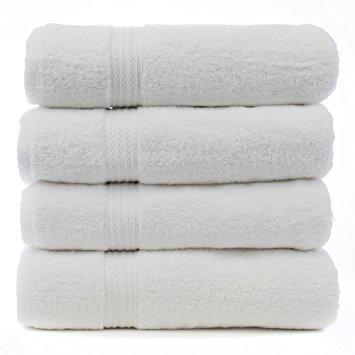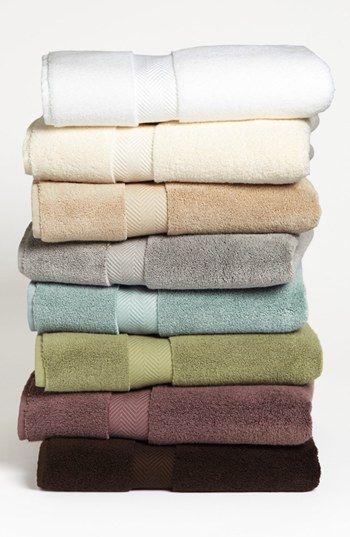The first image is the image on the left, the second image is the image on the right. Given the left and right images, does the statement "There are multiple colors of towels in the right image." hold true? Answer yes or no. Yes. The first image is the image on the left, the second image is the image on the right. For the images displayed, is the sentence "The left image shows a stack of four white folded towels, and the right image shows a stack of at least 8 folded towels of different solid colors." factually correct? Answer yes or no. Yes. 